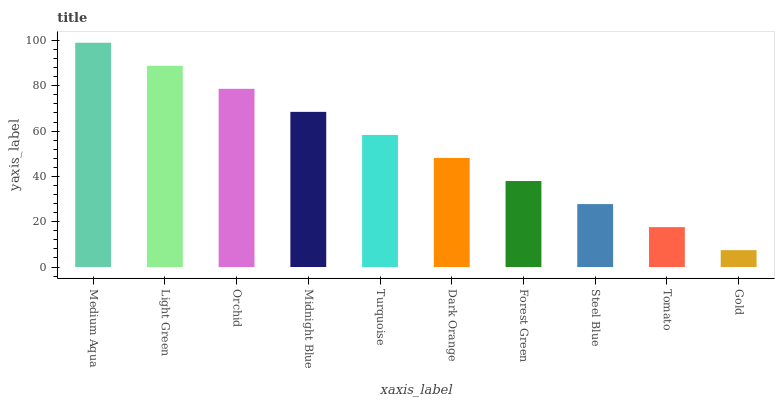Is Light Green the minimum?
Answer yes or no. No. Is Light Green the maximum?
Answer yes or no. No. Is Medium Aqua greater than Light Green?
Answer yes or no. Yes. Is Light Green less than Medium Aqua?
Answer yes or no. Yes. Is Light Green greater than Medium Aqua?
Answer yes or no. No. Is Medium Aqua less than Light Green?
Answer yes or no. No. Is Turquoise the high median?
Answer yes or no. Yes. Is Dark Orange the low median?
Answer yes or no. Yes. Is Tomato the high median?
Answer yes or no. No. Is Midnight Blue the low median?
Answer yes or no. No. 